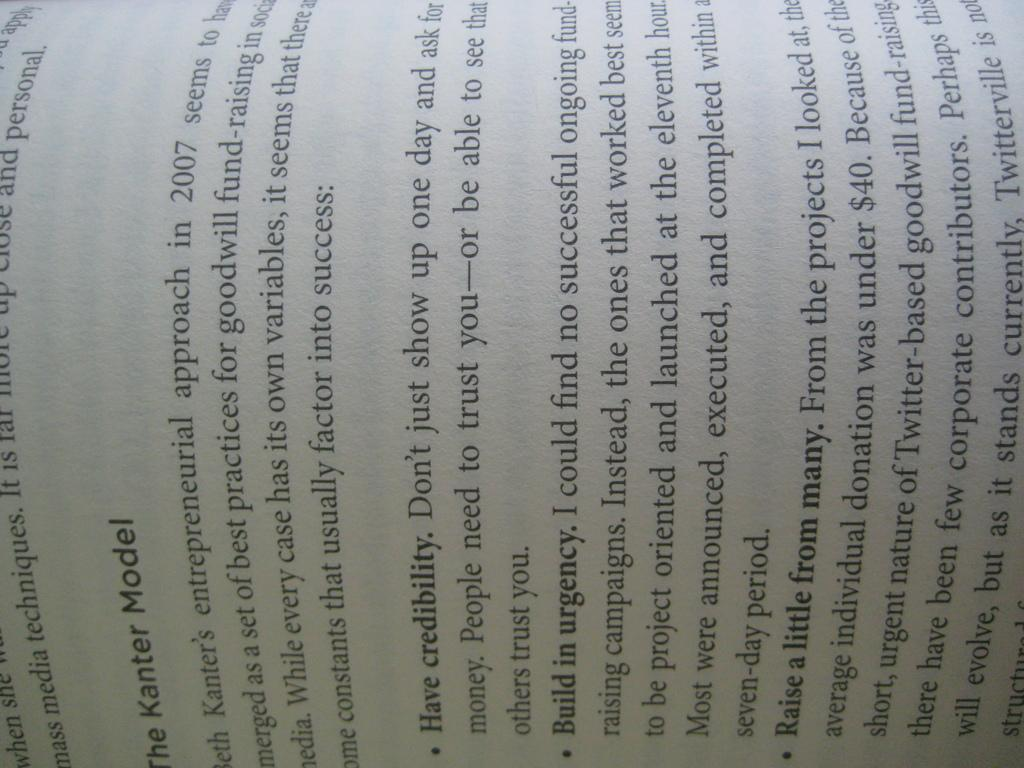<image>
Render a clear and concise summary of the photo. A book opened to the headline of The Kanter Model. 